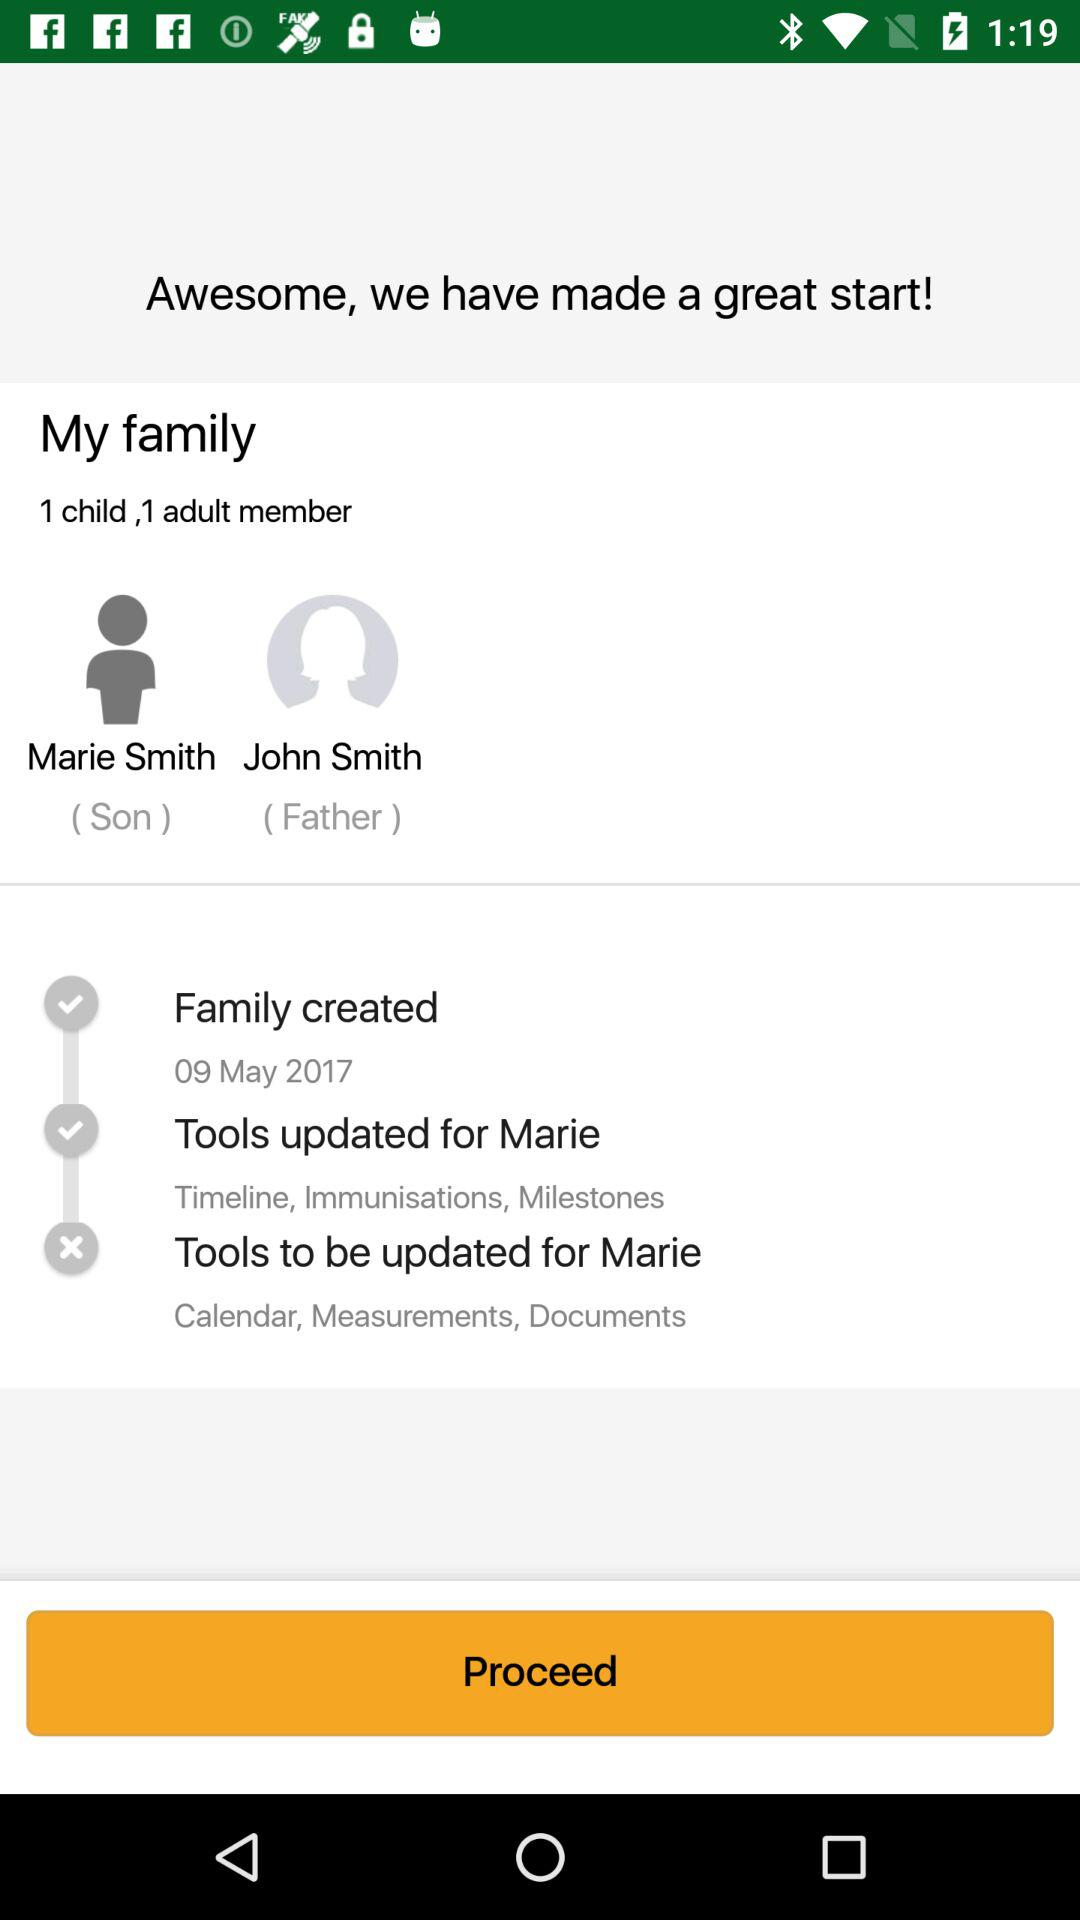How many total members are in family?
When the provided information is insufficient, respond with <no answer>. <no answer> 